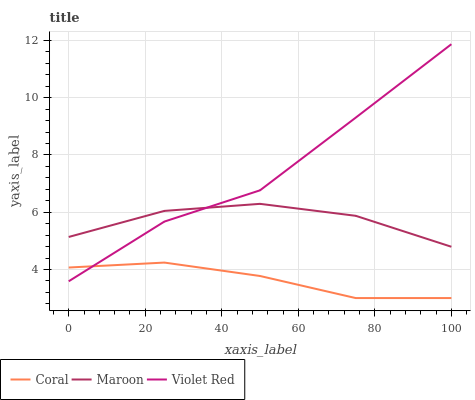Does Coral have the minimum area under the curve?
Answer yes or no. Yes. Does Violet Red have the maximum area under the curve?
Answer yes or no. Yes. Does Maroon have the minimum area under the curve?
Answer yes or no. No. Does Maroon have the maximum area under the curve?
Answer yes or no. No. Is Coral the smoothest?
Answer yes or no. Yes. Is Violet Red the roughest?
Answer yes or no. Yes. Is Maroon the smoothest?
Answer yes or no. No. Is Maroon the roughest?
Answer yes or no. No. Does Coral have the lowest value?
Answer yes or no. Yes. Does Violet Red have the lowest value?
Answer yes or no. No. Does Violet Red have the highest value?
Answer yes or no. Yes. Does Maroon have the highest value?
Answer yes or no. No. Is Coral less than Maroon?
Answer yes or no. Yes. Is Maroon greater than Coral?
Answer yes or no. Yes. Does Coral intersect Violet Red?
Answer yes or no. Yes. Is Coral less than Violet Red?
Answer yes or no. No. Is Coral greater than Violet Red?
Answer yes or no. No. Does Coral intersect Maroon?
Answer yes or no. No. 